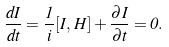<formula> <loc_0><loc_0><loc_500><loc_500>\frac { d I } { d t } = \frac { 1 } { i } [ I , \, H ] + \frac { \partial I } { \partial t } = 0 .</formula> 